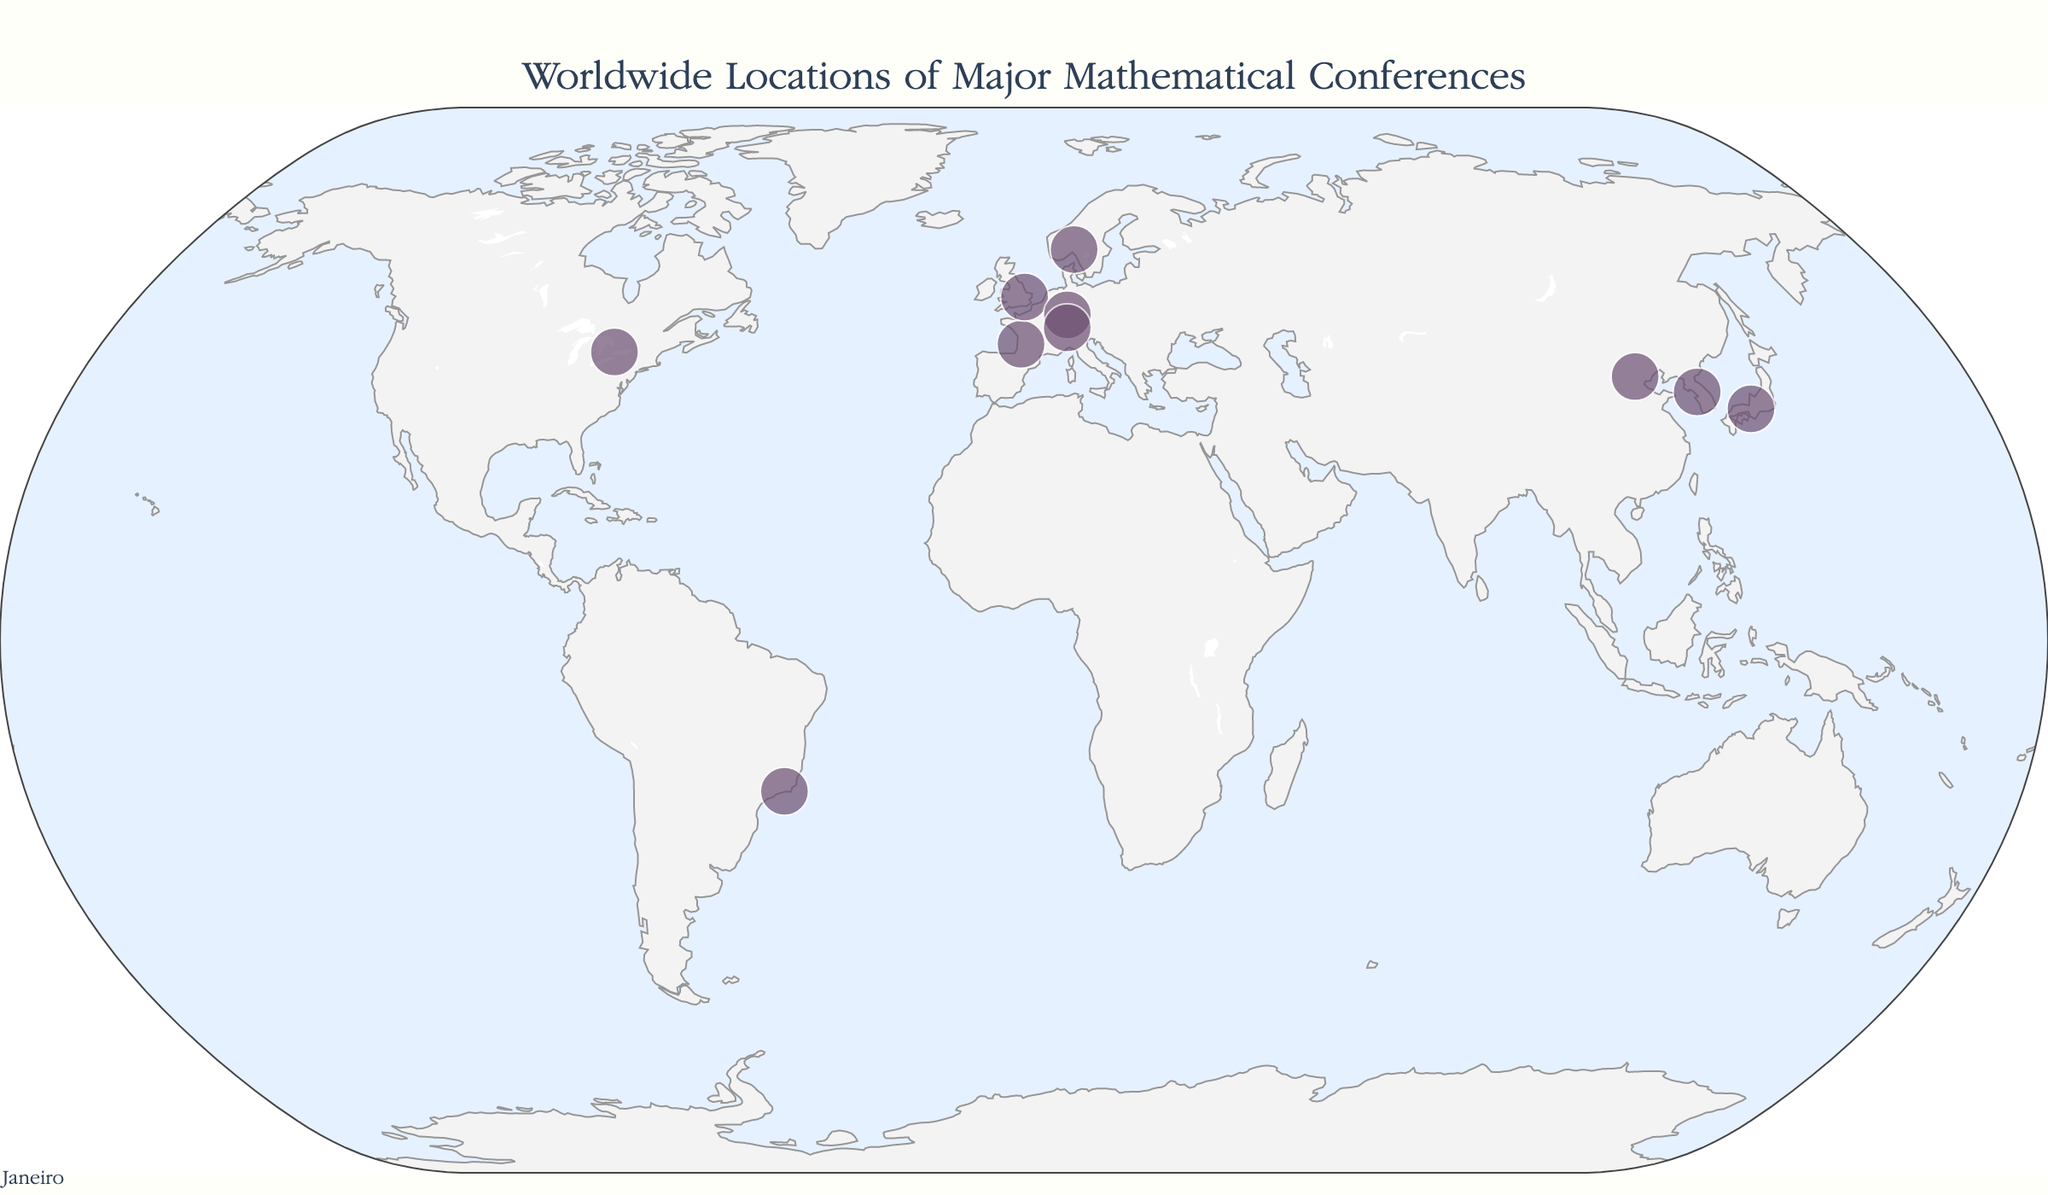How many major mathematical conferences are plotted on the map? Count each data point on the map to determine the total number of conferences.
Answer: 10 Which city in South America hosts a major mathematical conference? Identify the city located in South America by looking at the map and the annotations.
Answer: Rio de Janeiro Which event is held at the northernmost location? Find the annotation with the highest latitude on the map.
Answer: Journées Arithmétiques Are there more conferences held in Europe or in Asia? Count the number of conferences in Europe: Bordeaux, Oslo, Cambridge, Heidelberg, Zurich. Count the number of conferences in Asia: Beijing, Seoul, Kyoto. Compare the two totals.
Answer: Europe Which country hosts the International Congress of Mathematicians? Identify the country from the annotation related to the International Congress of Mathematicians.
Answer: Brazil What is the distance in latitude between the conferences held in Oslo and Cambridge? Subtract the latitude of Cambridge (52.2053) from the latitude of Oslo (59.9139).
Answer: 7.7086 Which two cities are closest to each other? Compare the geographical distances between each pair of cities. Look for cities with the smallest distance.
Answer: Cambridge and Heidelberg From the titles of the events, which conference focuses on Diophantine Analysis? Read the annotations for each event’s title until you find the one mentioning Diophantine Analysis.
Answer: Kyoto Are there any conferences located in the Southern Hemisphere? If yes, name the city. Check the latitude of each city plotted on the map. Locations with negative latitudes indicate the Southern Hemisphere.
Answer: Rio de Janeiro Which event occurs in France? Identify the annotation where the country is listed as France.
Answer: Algorithmic Number Theory Symposium 